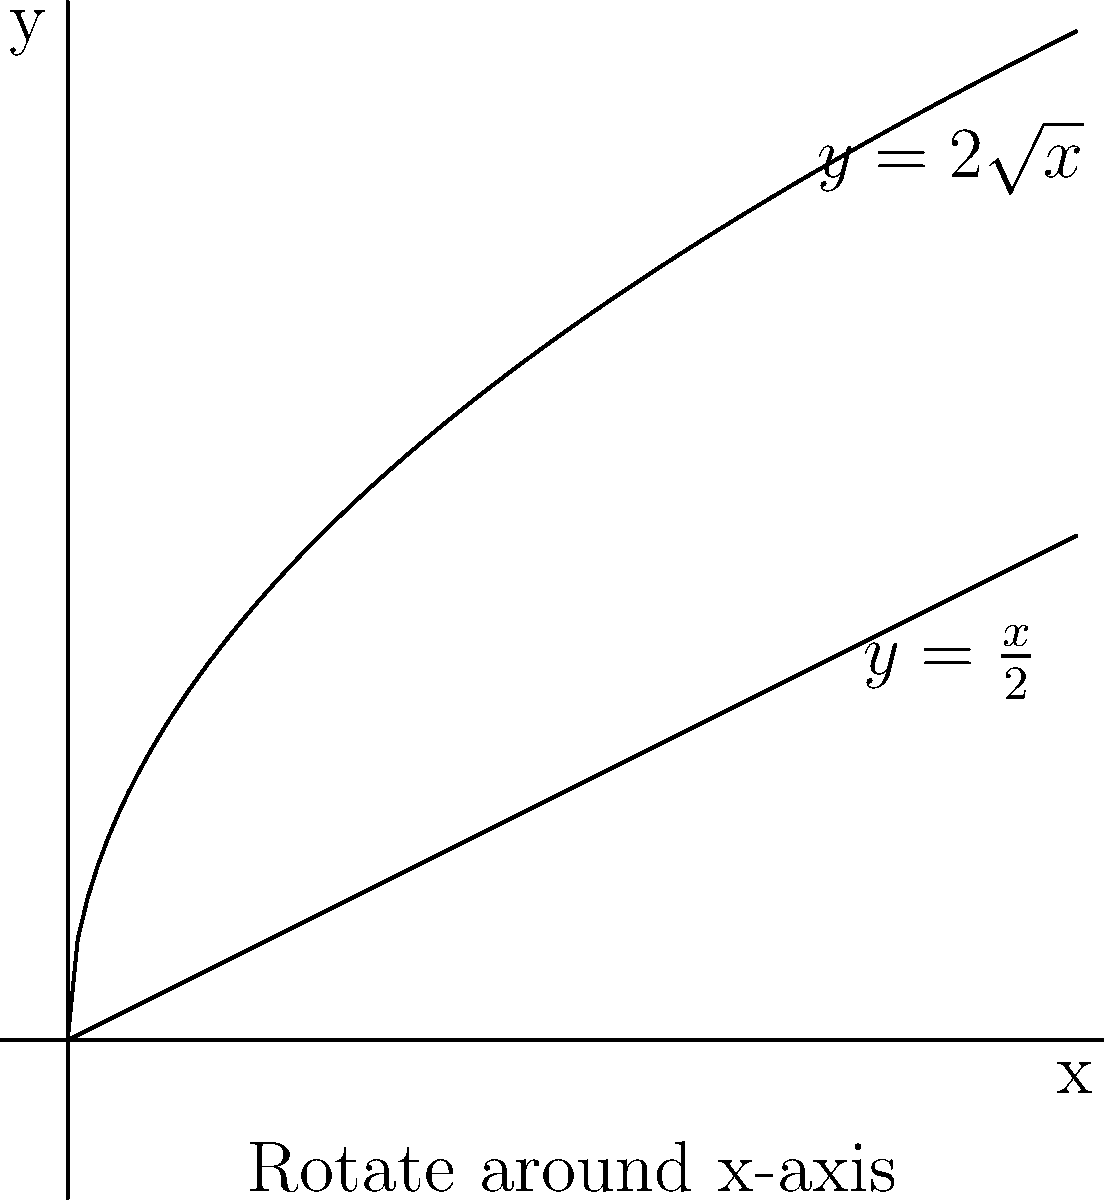As a figure skating coach, you're designing a unique trophy for your students. The trophy's shape is formed by rotating the region bounded by $y=2\sqrt{x}$, $y=\frac{x}{2}$, and the y-axis around the x-axis. Using the washer method, find the volume of this trophy. Round your answer to the nearest cubic inch. Let's approach this step-by-step:

1) The washer method formula for volume is:
   $$V = \pi \int_a^b [R(x)^2 - r(x)^2] dx$$
   where $R(x)$ is the outer function and $r(x)$ is the inner function.

2) In this case:
   $R(x) = 2\sqrt{x}$
   $r(x) = \frac{x}{2}$

3) We need to find the intersection point of these functions to determine $b$:
   $2\sqrt{x} = \frac{x}{2}$
   $4\sqrt{x} = x$
   $16x = x^2$
   $x^2 - 16x = 0$
   $x(x-16) = 0$
   $x = 0$ or $x = 16$
   The intersection point is at $x = 16$, but our graph only goes to 4, so $b = 4$.

4) Substituting into the volume formula:
   $$V = \pi \int_0^4 [(2\sqrt{x})^2 - (\frac{x}{2})^2] dx$$

5) Simplify:
   $$V = \pi \int_0^4 [4x - \frac{x^2}{4}] dx$$

6) Integrate:
   $$V = \pi [2x^2 - \frac{x^3}{12}]_0^4$$

7) Evaluate:
   $$V = \pi [(32 - \frac{64}{12}) - (0 - 0)]$$
   $$V = \pi [32 - \frac{16}{3}]$$
   $$V = \pi [\frac{96}{3} - \frac{16}{3}]$$
   $$V = \pi [\frac{80}{3}]$$
   $$V = \frac{80\pi}{3}$$

8) Calculate and round to the nearest cubic inch:
   $$V \approx 83.78 \approx 84 \text{ cubic inches}$$
Answer: 84 cubic inches 